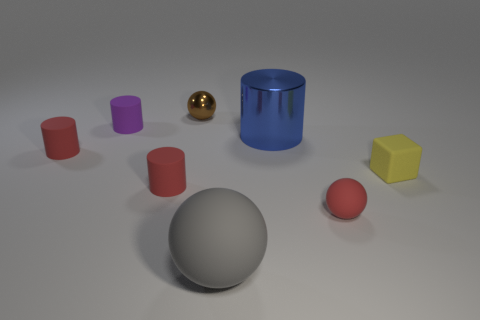Which object stands out the most, and why? The golden metallic ball stands out the most due to its shiny, reflective surface, and its distinct color that contrasts with the matte finish of the other objects and the muted colors in the rest of the scene. 